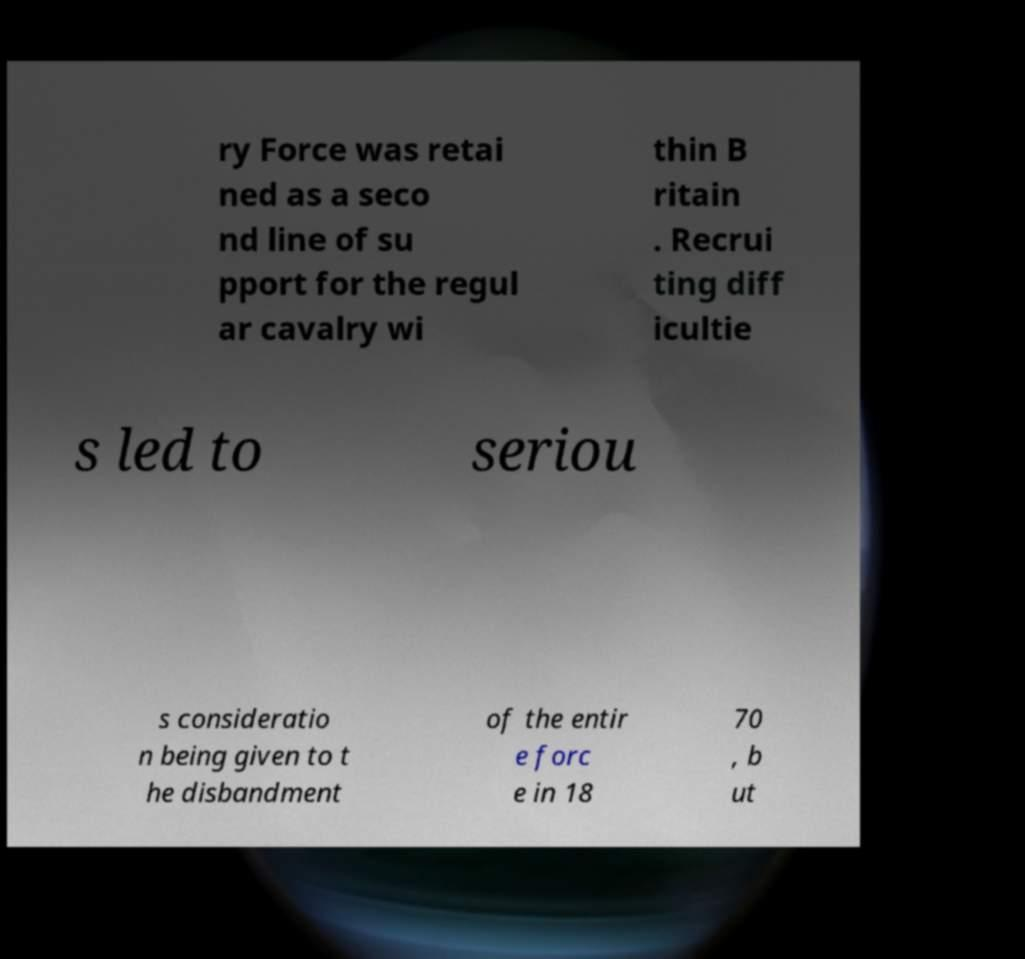Can you accurately transcribe the text from the provided image for me? ry Force was retai ned as a seco nd line of su pport for the regul ar cavalry wi thin B ritain . Recrui ting diff icultie s led to seriou s consideratio n being given to t he disbandment of the entir e forc e in 18 70 , b ut 